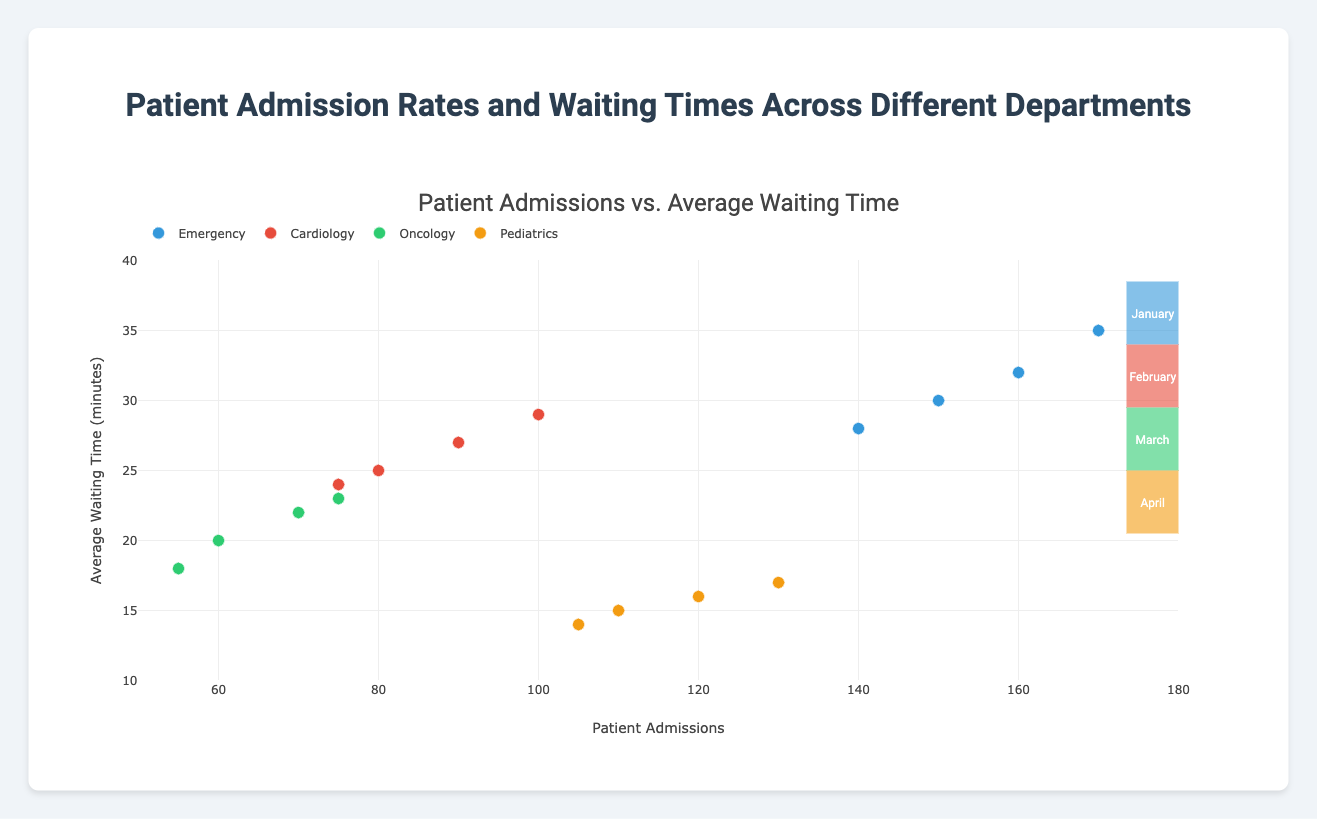What is the title of the plot? The title is displayed at the top and reads "Patient Admissions vs. Average Waiting Time".
Answer: Patient Admissions vs. Average Waiting Time Which department has the lowest average waiting time overall? By examining the y-axis positions of the markers, Pediatrics consistently demonstrates the lowest average waiting times across all months.
Answer: Pediatrics In which month did the Emergency department have the highest number of patient admissions? By looking at the x-axis values for the Emergency department's markers, the highest position corresponds to April.
Answer: April Compare the average waiting times in March for all departments. Which department had the highest waiting time? Identify markers for March, then compare their y-axis positions. Emergency in March is the highest.
Answer: Emergency Calculate the total number of patient admissions in January for all departments. Sum up the admissions for each department in January: 150 (Emergency) + 80 (Cardiology) + 60 (Oncology) + 110 (Pediatrics) = 400.
Answer: 400 Is there a month where the Oncology department has higher patient admissions than the Pediatrics department? Compare the x-axis values of Oncology and Pediatrics for each month. Pediatrics has higher admissions than Oncology every month.
Answer: No How does the waiting time for Pediatrics in April compare to Oncology in April? Locate the waiting times for both in April on the y-axis: 17 (Pediatrics) and 23 (Oncology). Pediatrics' waiting time is lower.
Answer: Lower What is the range of patient admissions across all departments in February? Identify the minimum and maximum patient admissions for February: Minimum (Oncology, 55) and Maximum (Emergency, 140). Range is 140 - 55 = 85.
Answer: 85 During which month did Cardiology see the smallest difference between patient admissions and waiting time? Compare the pairwise difference for each month: January (80-25=55), February (75-24=51), March (90-27=63), April (100-29=71). February has the smallest difference.
Answer: February 